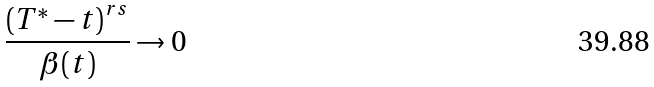Convert formula to latex. <formula><loc_0><loc_0><loc_500><loc_500>\frac { \left ( T ^ { * } - t \right ) ^ { r s } } { \beta ( t ) } \to 0</formula> 